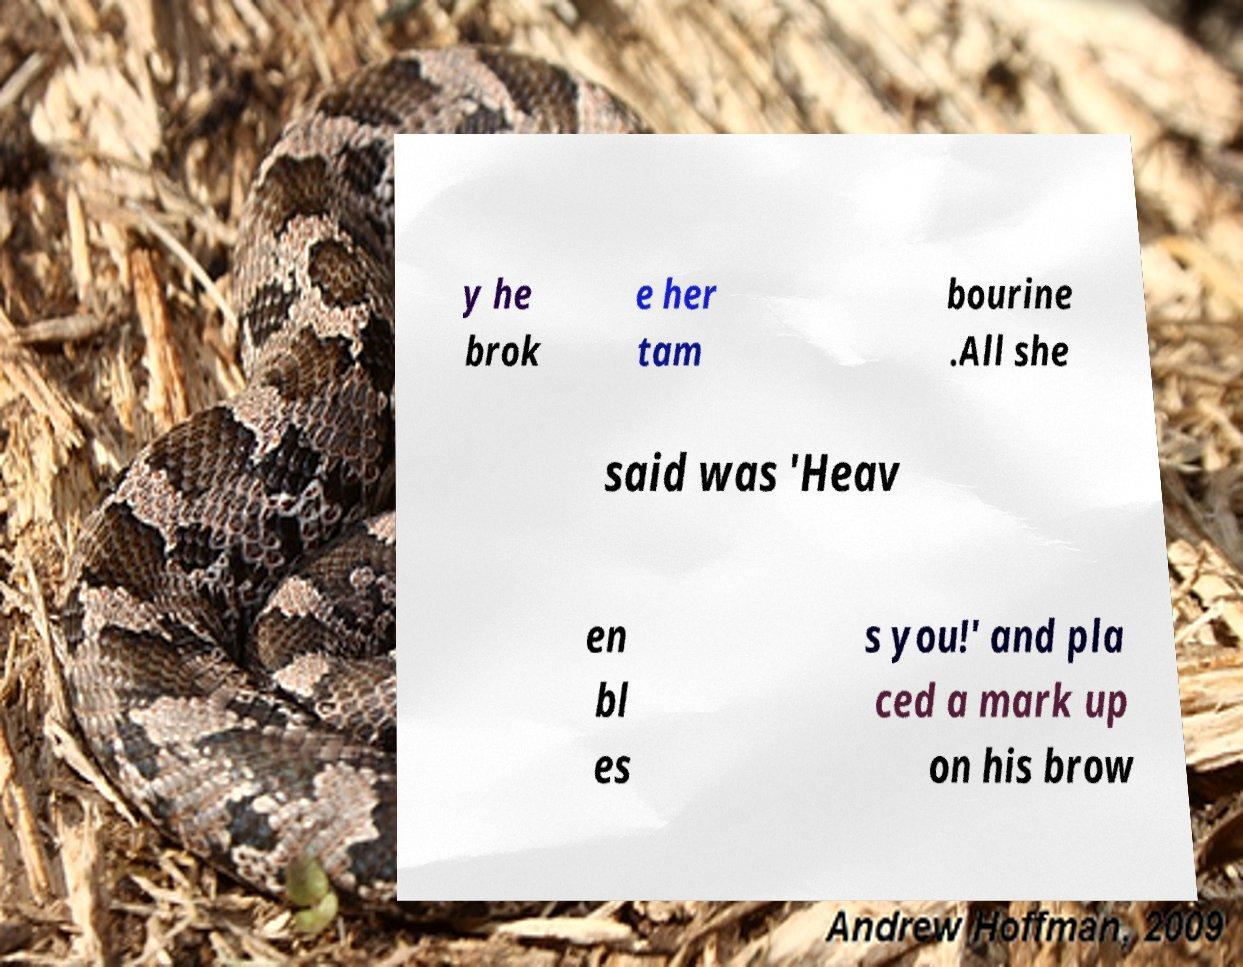There's text embedded in this image that I need extracted. Can you transcribe it verbatim? y he brok e her tam bourine .All she said was 'Heav en bl es s you!' and pla ced a mark up on his brow 